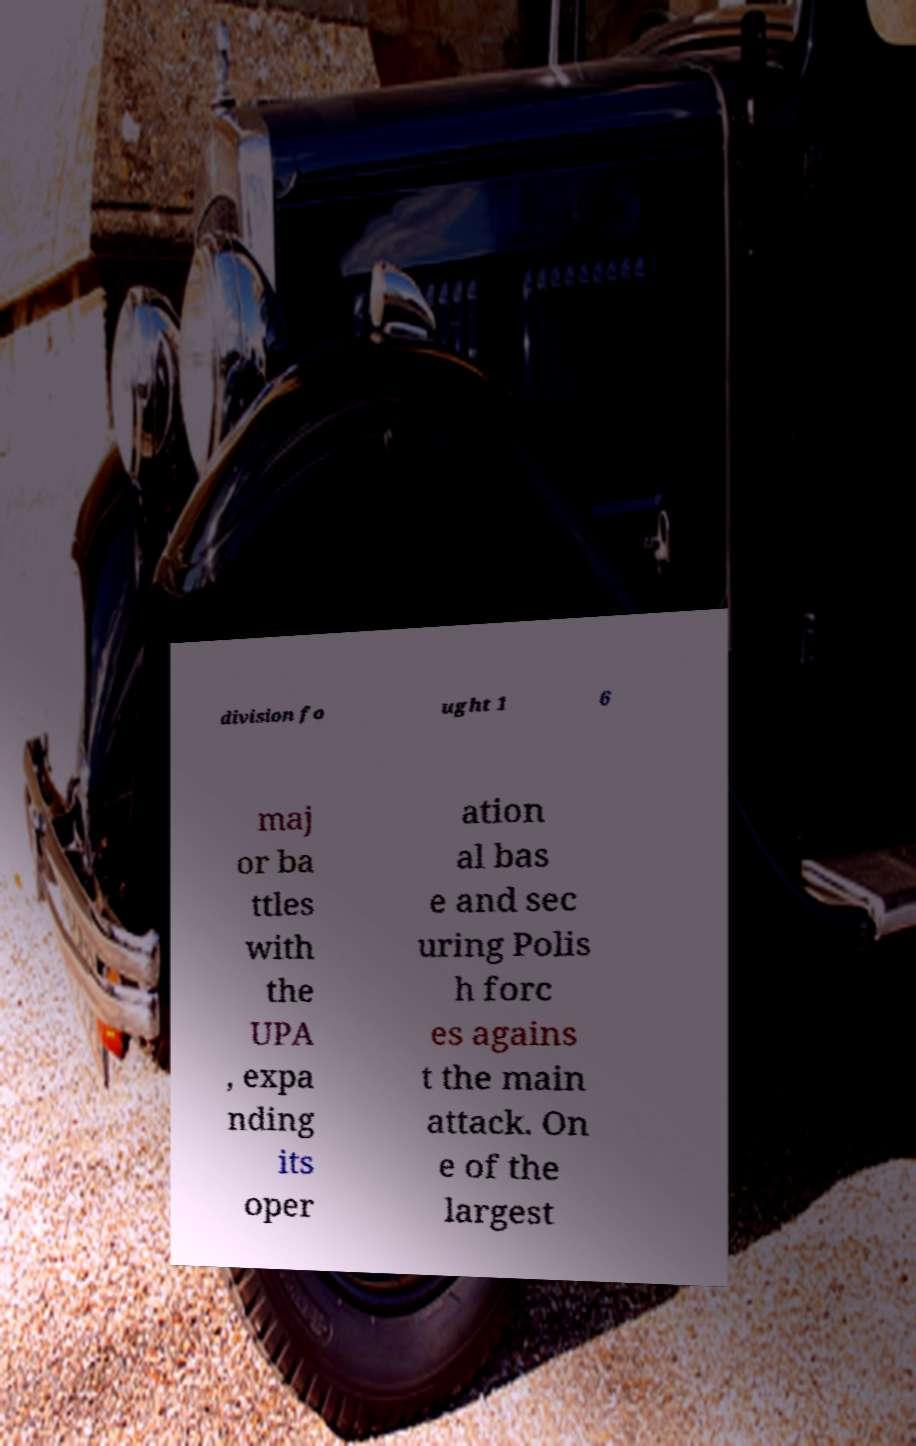What messages or text are displayed in this image? I need them in a readable, typed format. division fo ught 1 6 maj or ba ttles with the UPA , expa nding its oper ation al bas e and sec uring Polis h forc es agains t the main attack. On e of the largest 